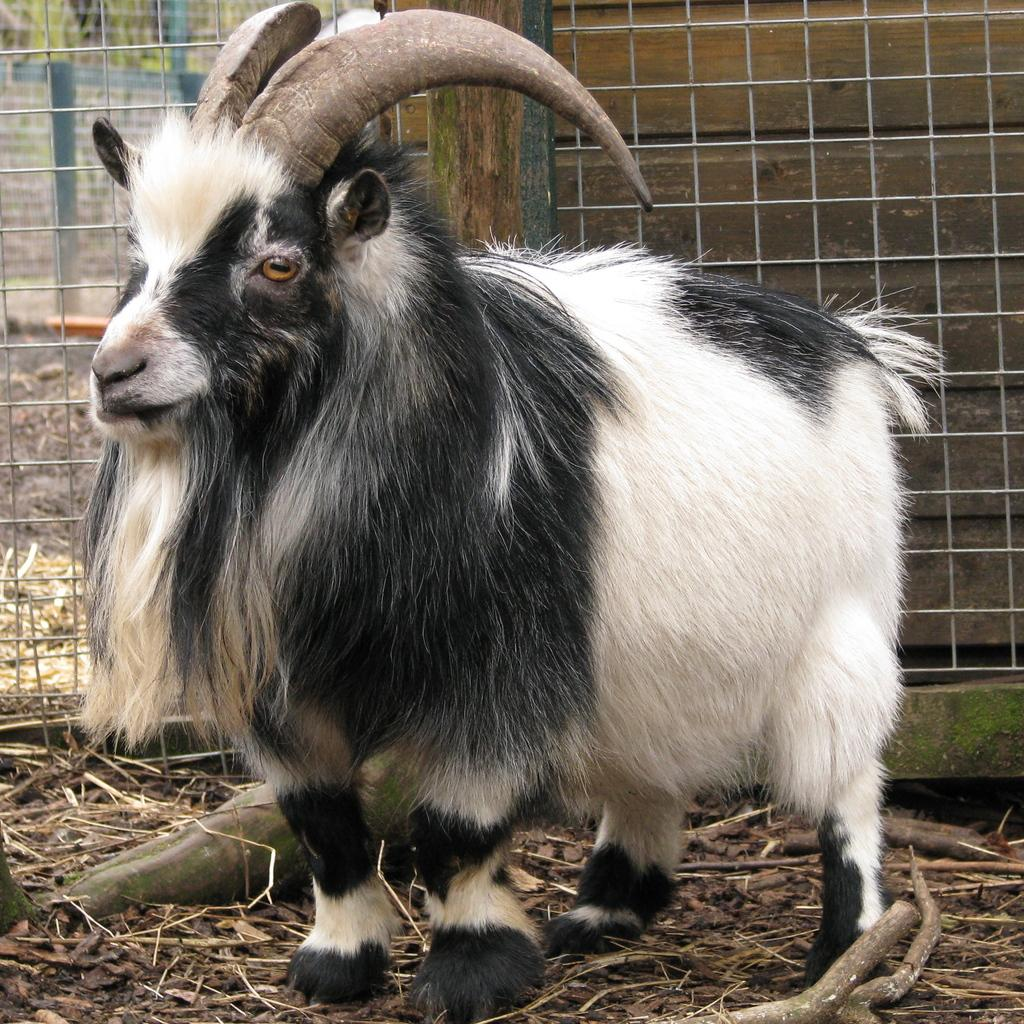What animal is present in the image? There is a goat in the image. What colors can be seen on the goat? The goat is black and white in color. What is located behind the goat in the image? There is an iron fencing behind the goat. Can you see any flowers growing on the trail in the image? There is no trail or flowers present in the image; it features a goat and an iron fencing. 